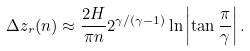Convert formula to latex. <formula><loc_0><loc_0><loc_500><loc_500>\Delta z _ { r } ( n ) \approx \frac { 2 H } { \pi n } 2 ^ { \gamma / ( \gamma - 1 ) } \ln \left | \tan \frac { \pi } { \gamma } \right | .</formula> 